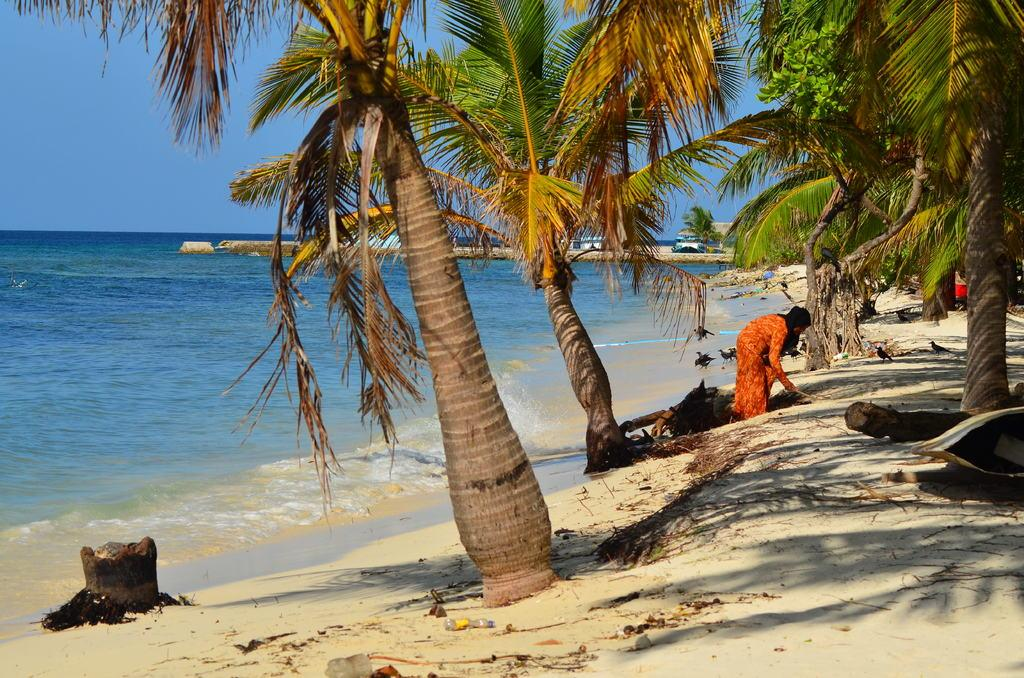What is the main subject of the image? There is a person in the image. What is the person doing in the image? The person is bending on the ground. What can be seen in the background of the image? There are trees, water, and sky visible in the background of the image. Can you describe the unspecified objects in the background of the image? Unfortunately, the provided facts do not specify the nature of the unspecified objects in the background. What type of toothpaste is being used by the person in the image? There is no toothpaste present in the image; the person is bending on the ground. What kind of waves can be seen in the water in the image? There are no waves visible in the water in the image; only still water is shown. 